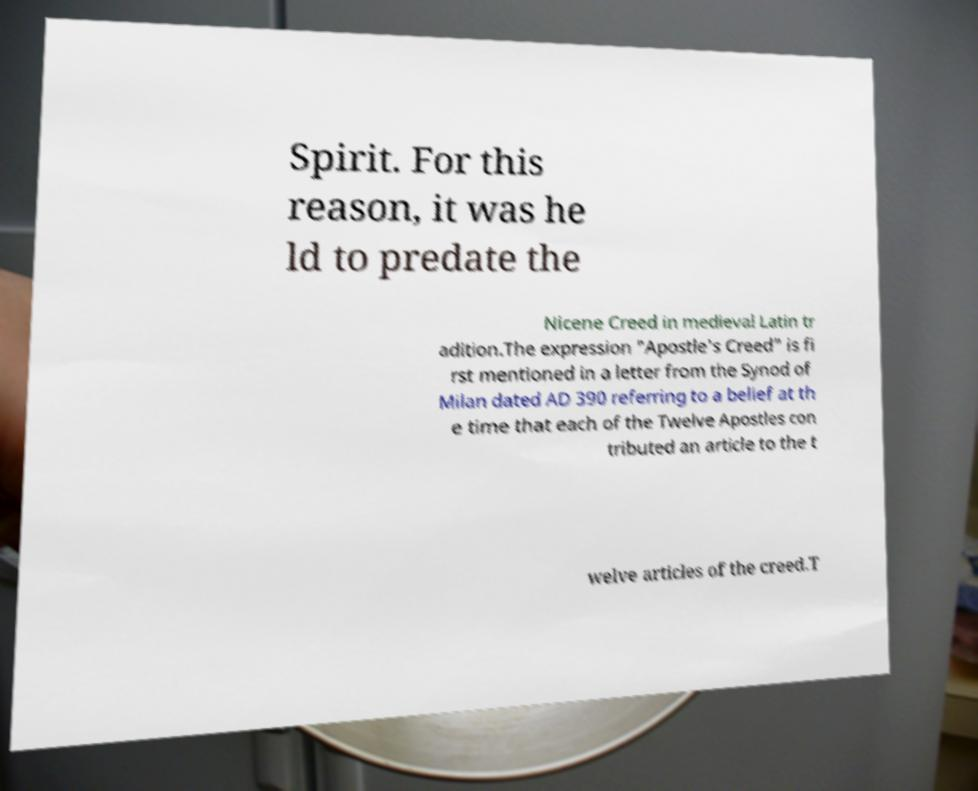Can you accurately transcribe the text from the provided image for me? Spirit. For this reason, it was he ld to predate the Nicene Creed in medieval Latin tr adition.The expression "Apostle's Creed" is fi rst mentioned in a letter from the Synod of Milan dated AD 390 referring to a belief at th e time that each of the Twelve Apostles con tributed an article to the t welve articles of the creed.T 